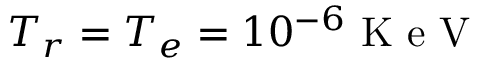Convert formula to latex. <formula><loc_0><loc_0><loc_500><loc_500>T _ { r } = T _ { e } = 1 0 ^ { - 6 } K e V</formula> 